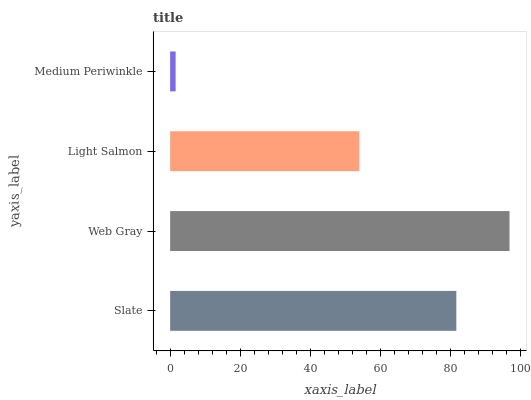Is Medium Periwinkle the minimum?
Answer yes or no. Yes. Is Web Gray the maximum?
Answer yes or no. Yes. Is Light Salmon the minimum?
Answer yes or no. No. Is Light Salmon the maximum?
Answer yes or no. No. Is Web Gray greater than Light Salmon?
Answer yes or no. Yes. Is Light Salmon less than Web Gray?
Answer yes or no. Yes. Is Light Salmon greater than Web Gray?
Answer yes or no. No. Is Web Gray less than Light Salmon?
Answer yes or no. No. Is Slate the high median?
Answer yes or no. Yes. Is Light Salmon the low median?
Answer yes or no. Yes. Is Medium Periwinkle the high median?
Answer yes or no. No. Is Web Gray the low median?
Answer yes or no. No. 